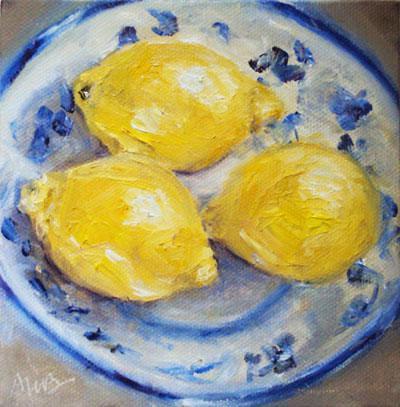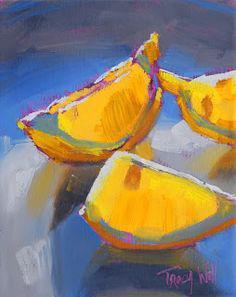The first image is the image on the left, the second image is the image on the right. Examine the images to the left and right. Is the description "The artwork of one image shows three whole lemons arranged in a bowl, while a second artwork image is of lemon wedges in blue shadows." accurate? Answer yes or no. Yes. 